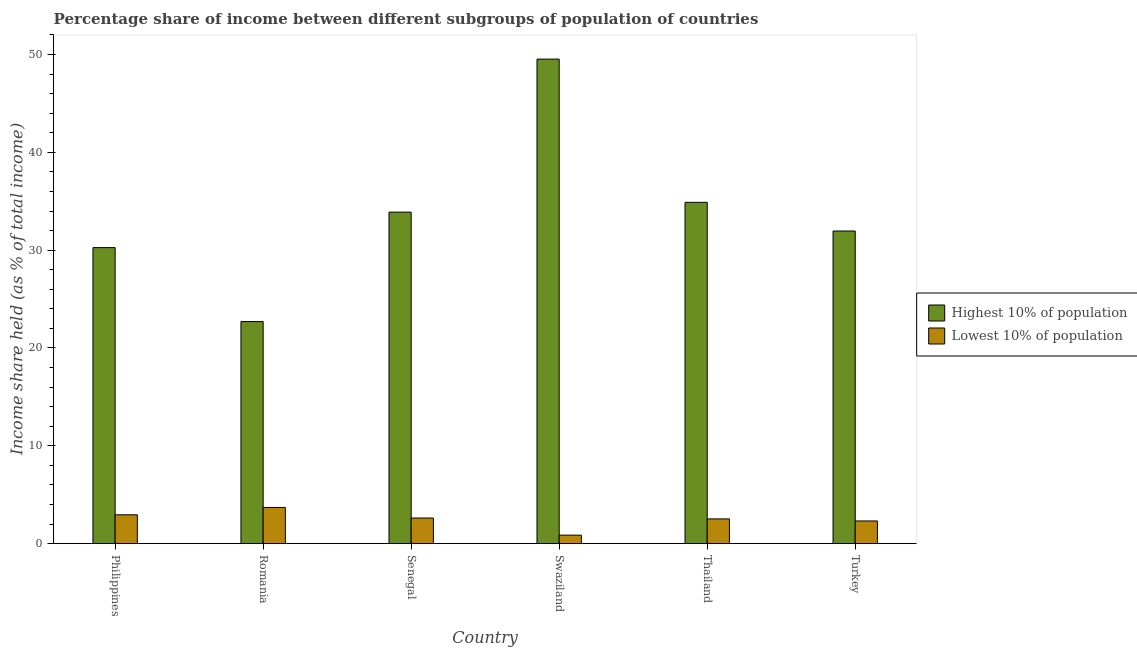How many groups of bars are there?
Offer a very short reply. 6. Are the number of bars per tick equal to the number of legend labels?
Your response must be concise. Yes. Are the number of bars on each tick of the X-axis equal?
Ensure brevity in your answer.  Yes. What is the label of the 4th group of bars from the left?
Offer a very short reply. Swaziland. What is the income share held by highest 10% of the population in Swaziland?
Make the answer very short. 49.53. Across all countries, what is the maximum income share held by highest 10% of the population?
Your answer should be compact. 49.53. Across all countries, what is the minimum income share held by lowest 10% of the population?
Your answer should be compact. 0.87. In which country was the income share held by lowest 10% of the population maximum?
Your answer should be very brief. Romania. In which country was the income share held by highest 10% of the population minimum?
Your answer should be very brief. Romania. What is the total income share held by lowest 10% of the population in the graph?
Provide a succinct answer. 14.99. What is the difference between the income share held by highest 10% of the population in Romania and that in Senegal?
Offer a terse response. -11.19. What is the difference between the income share held by lowest 10% of the population in Thailand and the income share held by highest 10% of the population in Turkey?
Ensure brevity in your answer.  -29.43. What is the average income share held by highest 10% of the population per country?
Keep it short and to the point. 33.87. What is the difference between the income share held by lowest 10% of the population and income share held by highest 10% of the population in Philippines?
Your response must be concise. -27.31. In how many countries, is the income share held by lowest 10% of the population greater than 34 %?
Give a very brief answer. 0. What is the ratio of the income share held by lowest 10% of the population in Philippines to that in Thailand?
Your answer should be very brief. 1.17. What is the difference between the highest and the second highest income share held by highest 10% of the population?
Your answer should be very brief. 14.64. What is the difference between the highest and the lowest income share held by lowest 10% of the population?
Keep it short and to the point. 2.83. In how many countries, is the income share held by highest 10% of the population greater than the average income share held by highest 10% of the population taken over all countries?
Offer a very short reply. 3. Is the sum of the income share held by highest 10% of the population in Philippines and Turkey greater than the maximum income share held by lowest 10% of the population across all countries?
Provide a succinct answer. Yes. What does the 1st bar from the left in Senegal represents?
Your answer should be compact. Highest 10% of population. What does the 2nd bar from the right in Turkey represents?
Keep it short and to the point. Highest 10% of population. How many countries are there in the graph?
Your answer should be compact. 6. What is the title of the graph?
Offer a terse response. Percentage share of income between different subgroups of population of countries. Does "Male labourers" appear as one of the legend labels in the graph?
Your response must be concise. No. What is the label or title of the Y-axis?
Provide a succinct answer. Income share held (as % of total income). What is the Income share held (as % of total income) in Highest 10% of population in Philippines?
Give a very brief answer. 30.26. What is the Income share held (as % of total income) in Lowest 10% of population in Philippines?
Give a very brief answer. 2.95. What is the Income share held (as % of total income) in Highest 10% of population in Romania?
Ensure brevity in your answer.  22.7. What is the Income share held (as % of total income) of Lowest 10% of population in Romania?
Give a very brief answer. 3.7. What is the Income share held (as % of total income) of Highest 10% of population in Senegal?
Offer a very short reply. 33.89. What is the Income share held (as % of total income) of Lowest 10% of population in Senegal?
Offer a very short reply. 2.62. What is the Income share held (as % of total income) of Highest 10% of population in Swaziland?
Give a very brief answer. 49.53. What is the Income share held (as % of total income) in Lowest 10% of population in Swaziland?
Ensure brevity in your answer.  0.87. What is the Income share held (as % of total income) of Highest 10% of population in Thailand?
Offer a very short reply. 34.89. What is the Income share held (as % of total income) in Lowest 10% of population in Thailand?
Provide a succinct answer. 2.53. What is the Income share held (as % of total income) of Highest 10% of population in Turkey?
Your response must be concise. 31.96. What is the Income share held (as % of total income) of Lowest 10% of population in Turkey?
Your answer should be very brief. 2.32. Across all countries, what is the maximum Income share held (as % of total income) of Highest 10% of population?
Your response must be concise. 49.53. Across all countries, what is the maximum Income share held (as % of total income) of Lowest 10% of population?
Keep it short and to the point. 3.7. Across all countries, what is the minimum Income share held (as % of total income) of Highest 10% of population?
Provide a succinct answer. 22.7. Across all countries, what is the minimum Income share held (as % of total income) of Lowest 10% of population?
Keep it short and to the point. 0.87. What is the total Income share held (as % of total income) in Highest 10% of population in the graph?
Offer a very short reply. 203.23. What is the total Income share held (as % of total income) in Lowest 10% of population in the graph?
Offer a very short reply. 14.99. What is the difference between the Income share held (as % of total income) of Highest 10% of population in Philippines and that in Romania?
Provide a succinct answer. 7.56. What is the difference between the Income share held (as % of total income) in Lowest 10% of population in Philippines and that in Romania?
Your answer should be compact. -0.75. What is the difference between the Income share held (as % of total income) in Highest 10% of population in Philippines and that in Senegal?
Give a very brief answer. -3.63. What is the difference between the Income share held (as % of total income) in Lowest 10% of population in Philippines and that in Senegal?
Your response must be concise. 0.33. What is the difference between the Income share held (as % of total income) of Highest 10% of population in Philippines and that in Swaziland?
Offer a very short reply. -19.27. What is the difference between the Income share held (as % of total income) of Lowest 10% of population in Philippines and that in Swaziland?
Provide a succinct answer. 2.08. What is the difference between the Income share held (as % of total income) in Highest 10% of population in Philippines and that in Thailand?
Your answer should be very brief. -4.63. What is the difference between the Income share held (as % of total income) in Lowest 10% of population in Philippines and that in Thailand?
Give a very brief answer. 0.42. What is the difference between the Income share held (as % of total income) of Lowest 10% of population in Philippines and that in Turkey?
Your response must be concise. 0.63. What is the difference between the Income share held (as % of total income) in Highest 10% of population in Romania and that in Senegal?
Make the answer very short. -11.19. What is the difference between the Income share held (as % of total income) in Highest 10% of population in Romania and that in Swaziland?
Give a very brief answer. -26.83. What is the difference between the Income share held (as % of total income) in Lowest 10% of population in Romania and that in Swaziland?
Ensure brevity in your answer.  2.83. What is the difference between the Income share held (as % of total income) of Highest 10% of population in Romania and that in Thailand?
Keep it short and to the point. -12.19. What is the difference between the Income share held (as % of total income) of Lowest 10% of population in Romania and that in Thailand?
Your answer should be very brief. 1.17. What is the difference between the Income share held (as % of total income) of Highest 10% of population in Romania and that in Turkey?
Provide a succinct answer. -9.26. What is the difference between the Income share held (as % of total income) of Lowest 10% of population in Romania and that in Turkey?
Make the answer very short. 1.38. What is the difference between the Income share held (as % of total income) of Highest 10% of population in Senegal and that in Swaziland?
Give a very brief answer. -15.64. What is the difference between the Income share held (as % of total income) of Highest 10% of population in Senegal and that in Thailand?
Give a very brief answer. -1. What is the difference between the Income share held (as % of total income) of Lowest 10% of population in Senegal and that in Thailand?
Give a very brief answer. 0.09. What is the difference between the Income share held (as % of total income) of Highest 10% of population in Senegal and that in Turkey?
Make the answer very short. 1.93. What is the difference between the Income share held (as % of total income) in Lowest 10% of population in Senegal and that in Turkey?
Offer a very short reply. 0.3. What is the difference between the Income share held (as % of total income) in Highest 10% of population in Swaziland and that in Thailand?
Give a very brief answer. 14.64. What is the difference between the Income share held (as % of total income) of Lowest 10% of population in Swaziland and that in Thailand?
Keep it short and to the point. -1.66. What is the difference between the Income share held (as % of total income) in Highest 10% of population in Swaziland and that in Turkey?
Keep it short and to the point. 17.57. What is the difference between the Income share held (as % of total income) in Lowest 10% of population in Swaziland and that in Turkey?
Offer a terse response. -1.45. What is the difference between the Income share held (as % of total income) of Highest 10% of population in Thailand and that in Turkey?
Ensure brevity in your answer.  2.93. What is the difference between the Income share held (as % of total income) of Lowest 10% of population in Thailand and that in Turkey?
Provide a succinct answer. 0.21. What is the difference between the Income share held (as % of total income) in Highest 10% of population in Philippines and the Income share held (as % of total income) in Lowest 10% of population in Romania?
Provide a short and direct response. 26.56. What is the difference between the Income share held (as % of total income) of Highest 10% of population in Philippines and the Income share held (as % of total income) of Lowest 10% of population in Senegal?
Keep it short and to the point. 27.64. What is the difference between the Income share held (as % of total income) in Highest 10% of population in Philippines and the Income share held (as % of total income) in Lowest 10% of population in Swaziland?
Offer a terse response. 29.39. What is the difference between the Income share held (as % of total income) in Highest 10% of population in Philippines and the Income share held (as % of total income) in Lowest 10% of population in Thailand?
Provide a short and direct response. 27.73. What is the difference between the Income share held (as % of total income) in Highest 10% of population in Philippines and the Income share held (as % of total income) in Lowest 10% of population in Turkey?
Give a very brief answer. 27.94. What is the difference between the Income share held (as % of total income) in Highest 10% of population in Romania and the Income share held (as % of total income) in Lowest 10% of population in Senegal?
Offer a terse response. 20.08. What is the difference between the Income share held (as % of total income) in Highest 10% of population in Romania and the Income share held (as % of total income) in Lowest 10% of population in Swaziland?
Your answer should be compact. 21.83. What is the difference between the Income share held (as % of total income) of Highest 10% of population in Romania and the Income share held (as % of total income) of Lowest 10% of population in Thailand?
Your response must be concise. 20.17. What is the difference between the Income share held (as % of total income) in Highest 10% of population in Romania and the Income share held (as % of total income) in Lowest 10% of population in Turkey?
Provide a succinct answer. 20.38. What is the difference between the Income share held (as % of total income) in Highest 10% of population in Senegal and the Income share held (as % of total income) in Lowest 10% of population in Swaziland?
Offer a very short reply. 33.02. What is the difference between the Income share held (as % of total income) in Highest 10% of population in Senegal and the Income share held (as % of total income) in Lowest 10% of population in Thailand?
Keep it short and to the point. 31.36. What is the difference between the Income share held (as % of total income) in Highest 10% of population in Senegal and the Income share held (as % of total income) in Lowest 10% of population in Turkey?
Offer a very short reply. 31.57. What is the difference between the Income share held (as % of total income) in Highest 10% of population in Swaziland and the Income share held (as % of total income) in Lowest 10% of population in Thailand?
Your response must be concise. 47. What is the difference between the Income share held (as % of total income) in Highest 10% of population in Swaziland and the Income share held (as % of total income) in Lowest 10% of population in Turkey?
Provide a short and direct response. 47.21. What is the difference between the Income share held (as % of total income) of Highest 10% of population in Thailand and the Income share held (as % of total income) of Lowest 10% of population in Turkey?
Give a very brief answer. 32.57. What is the average Income share held (as % of total income) of Highest 10% of population per country?
Offer a very short reply. 33.87. What is the average Income share held (as % of total income) in Lowest 10% of population per country?
Offer a terse response. 2.5. What is the difference between the Income share held (as % of total income) in Highest 10% of population and Income share held (as % of total income) in Lowest 10% of population in Philippines?
Your answer should be very brief. 27.31. What is the difference between the Income share held (as % of total income) of Highest 10% of population and Income share held (as % of total income) of Lowest 10% of population in Senegal?
Your answer should be very brief. 31.27. What is the difference between the Income share held (as % of total income) of Highest 10% of population and Income share held (as % of total income) of Lowest 10% of population in Swaziland?
Your response must be concise. 48.66. What is the difference between the Income share held (as % of total income) of Highest 10% of population and Income share held (as % of total income) of Lowest 10% of population in Thailand?
Ensure brevity in your answer.  32.36. What is the difference between the Income share held (as % of total income) in Highest 10% of population and Income share held (as % of total income) in Lowest 10% of population in Turkey?
Offer a terse response. 29.64. What is the ratio of the Income share held (as % of total income) in Highest 10% of population in Philippines to that in Romania?
Offer a very short reply. 1.33. What is the ratio of the Income share held (as % of total income) in Lowest 10% of population in Philippines to that in Romania?
Your response must be concise. 0.8. What is the ratio of the Income share held (as % of total income) in Highest 10% of population in Philippines to that in Senegal?
Provide a short and direct response. 0.89. What is the ratio of the Income share held (as % of total income) of Lowest 10% of population in Philippines to that in Senegal?
Offer a very short reply. 1.13. What is the ratio of the Income share held (as % of total income) of Highest 10% of population in Philippines to that in Swaziland?
Provide a succinct answer. 0.61. What is the ratio of the Income share held (as % of total income) of Lowest 10% of population in Philippines to that in Swaziland?
Provide a succinct answer. 3.39. What is the ratio of the Income share held (as % of total income) in Highest 10% of population in Philippines to that in Thailand?
Give a very brief answer. 0.87. What is the ratio of the Income share held (as % of total income) of Lowest 10% of population in Philippines to that in Thailand?
Provide a short and direct response. 1.17. What is the ratio of the Income share held (as % of total income) of Highest 10% of population in Philippines to that in Turkey?
Keep it short and to the point. 0.95. What is the ratio of the Income share held (as % of total income) in Lowest 10% of population in Philippines to that in Turkey?
Offer a very short reply. 1.27. What is the ratio of the Income share held (as % of total income) in Highest 10% of population in Romania to that in Senegal?
Offer a terse response. 0.67. What is the ratio of the Income share held (as % of total income) of Lowest 10% of population in Romania to that in Senegal?
Make the answer very short. 1.41. What is the ratio of the Income share held (as % of total income) in Highest 10% of population in Romania to that in Swaziland?
Ensure brevity in your answer.  0.46. What is the ratio of the Income share held (as % of total income) of Lowest 10% of population in Romania to that in Swaziland?
Provide a succinct answer. 4.25. What is the ratio of the Income share held (as % of total income) of Highest 10% of population in Romania to that in Thailand?
Provide a succinct answer. 0.65. What is the ratio of the Income share held (as % of total income) in Lowest 10% of population in Romania to that in Thailand?
Make the answer very short. 1.46. What is the ratio of the Income share held (as % of total income) in Highest 10% of population in Romania to that in Turkey?
Provide a short and direct response. 0.71. What is the ratio of the Income share held (as % of total income) in Lowest 10% of population in Romania to that in Turkey?
Your response must be concise. 1.59. What is the ratio of the Income share held (as % of total income) of Highest 10% of population in Senegal to that in Swaziland?
Keep it short and to the point. 0.68. What is the ratio of the Income share held (as % of total income) in Lowest 10% of population in Senegal to that in Swaziland?
Your answer should be very brief. 3.01. What is the ratio of the Income share held (as % of total income) in Highest 10% of population in Senegal to that in Thailand?
Your answer should be compact. 0.97. What is the ratio of the Income share held (as % of total income) of Lowest 10% of population in Senegal to that in Thailand?
Your answer should be compact. 1.04. What is the ratio of the Income share held (as % of total income) of Highest 10% of population in Senegal to that in Turkey?
Provide a short and direct response. 1.06. What is the ratio of the Income share held (as % of total income) in Lowest 10% of population in Senegal to that in Turkey?
Your answer should be very brief. 1.13. What is the ratio of the Income share held (as % of total income) in Highest 10% of population in Swaziland to that in Thailand?
Keep it short and to the point. 1.42. What is the ratio of the Income share held (as % of total income) of Lowest 10% of population in Swaziland to that in Thailand?
Your answer should be compact. 0.34. What is the ratio of the Income share held (as % of total income) in Highest 10% of population in Swaziland to that in Turkey?
Provide a short and direct response. 1.55. What is the ratio of the Income share held (as % of total income) in Lowest 10% of population in Swaziland to that in Turkey?
Provide a succinct answer. 0.38. What is the ratio of the Income share held (as % of total income) of Highest 10% of population in Thailand to that in Turkey?
Offer a terse response. 1.09. What is the ratio of the Income share held (as % of total income) in Lowest 10% of population in Thailand to that in Turkey?
Give a very brief answer. 1.09. What is the difference between the highest and the second highest Income share held (as % of total income) of Highest 10% of population?
Ensure brevity in your answer.  14.64. What is the difference between the highest and the second highest Income share held (as % of total income) of Lowest 10% of population?
Offer a very short reply. 0.75. What is the difference between the highest and the lowest Income share held (as % of total income) in Highest 10% of population?
Your answer should be very brief. 26.83. What is the difference between the highest and the lowest Income share held (as % of total income) in Lowest 10% of population?
Your response must be concise. 2.83. 